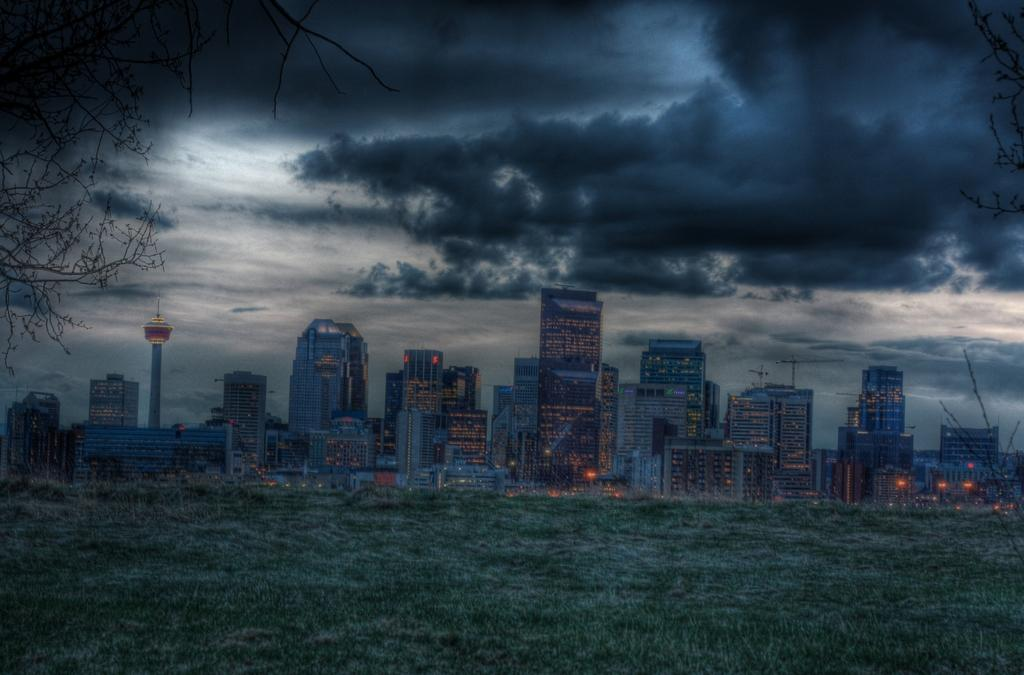What type of buildings can be seen in the image? There are skyscrapers in the image. What is located in the front of the image? There is a grass lawn in the front of the image. What part of the natural environment is visible in the image? The sky is visible in the image. What can be seen in the sky? Clouds are present in the sky. How many dimes are scattered on the grass lawn in the image? There are no dimes present on the grass lawn in the image. 